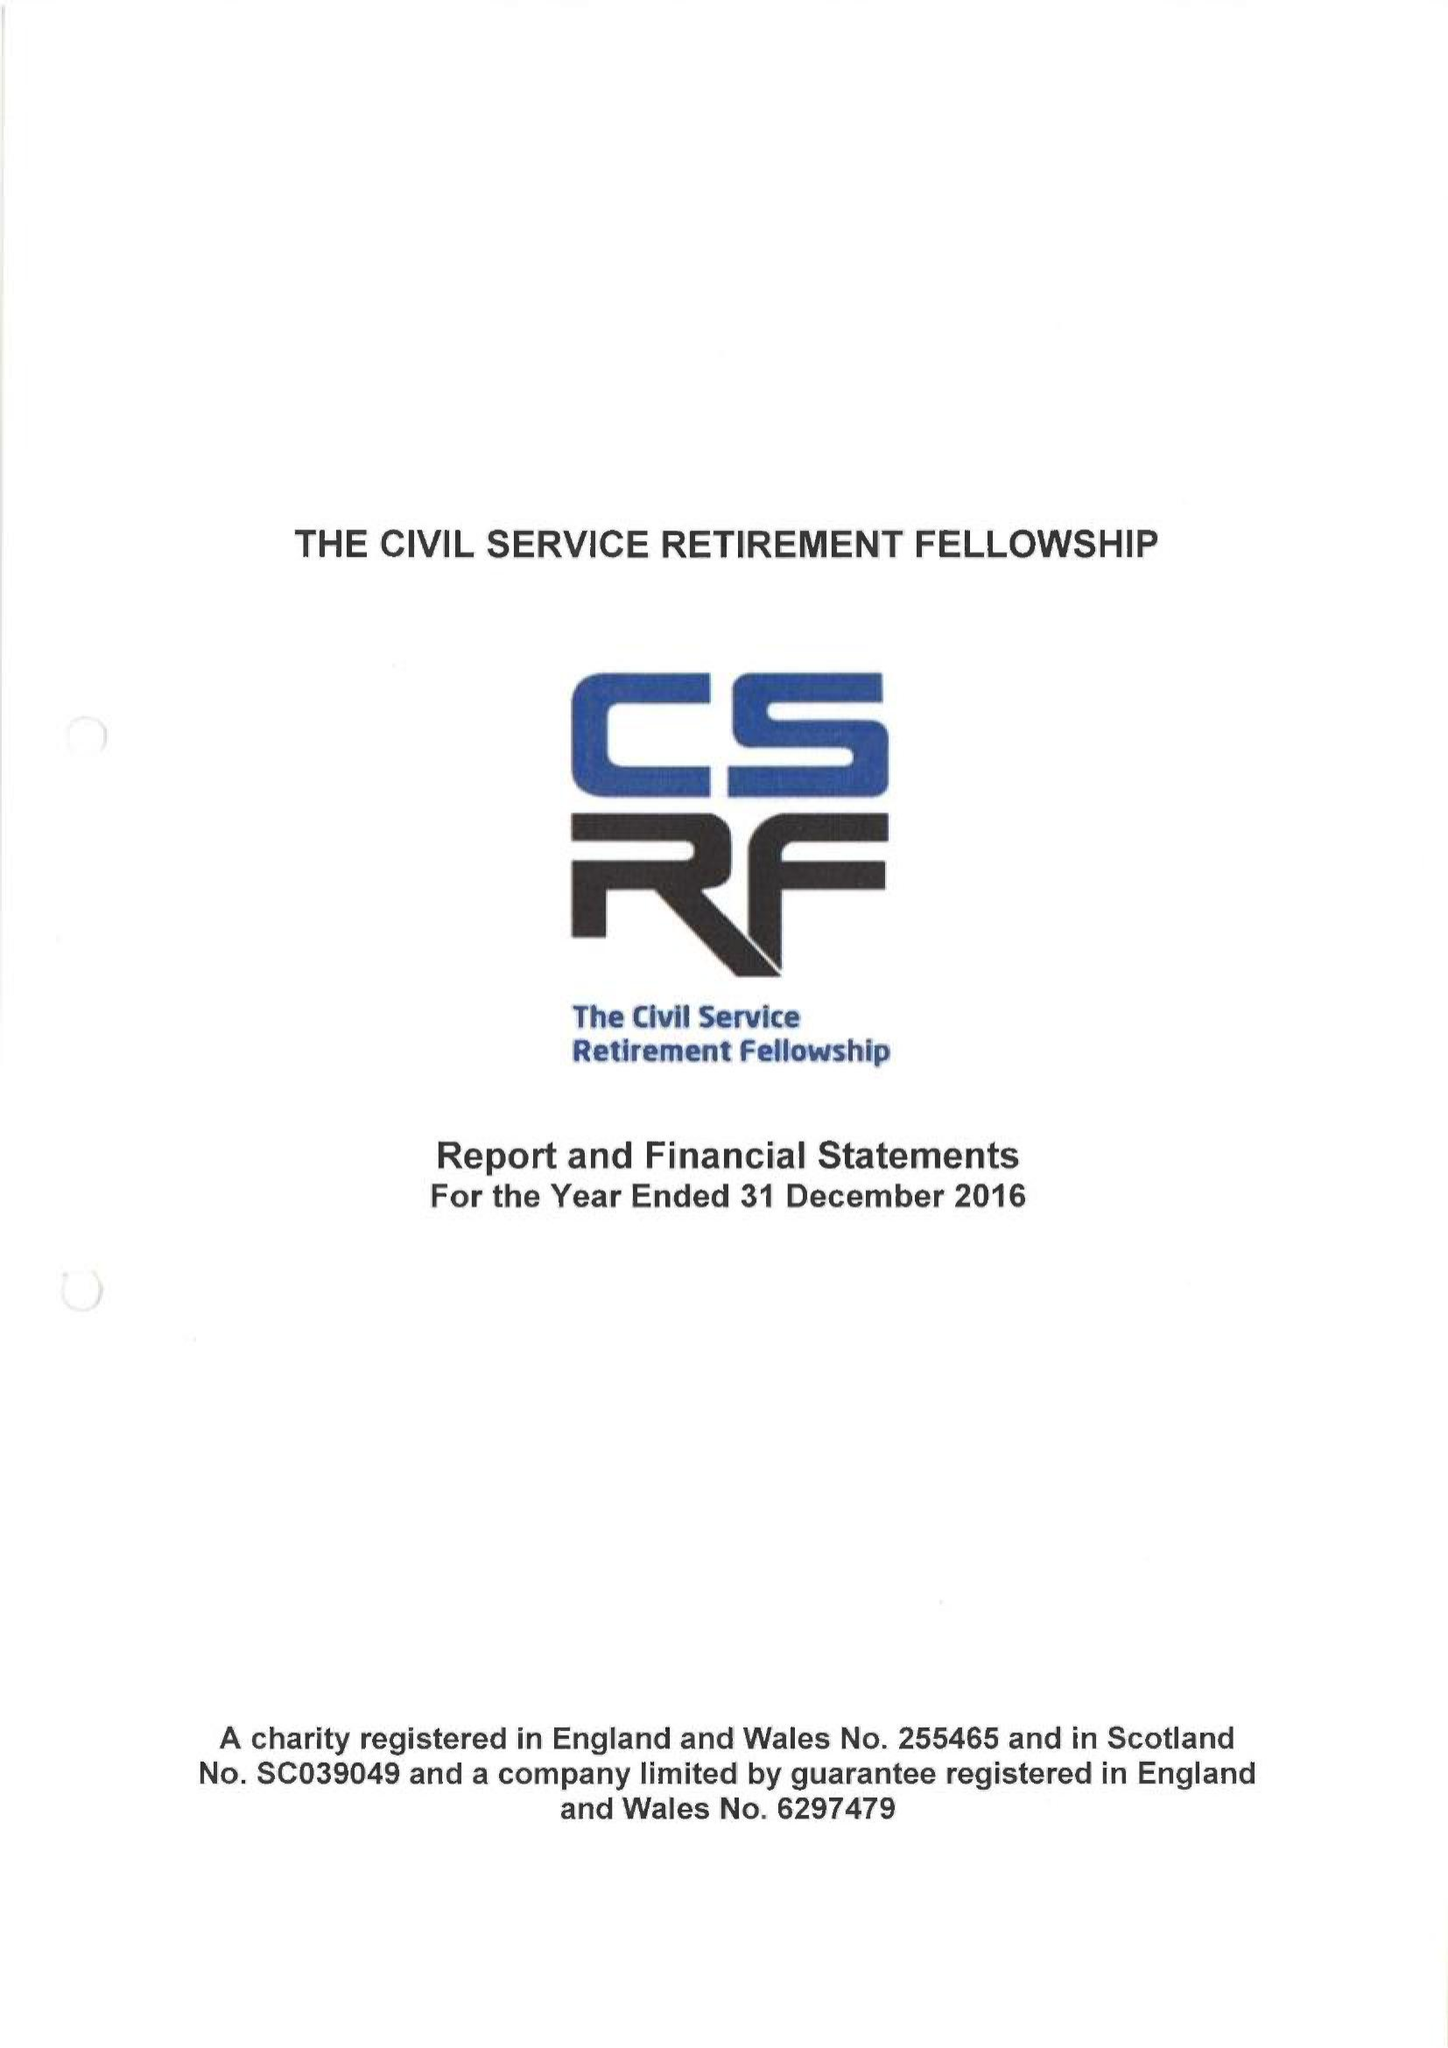What is the value for the address__postcode?
Answer the question using a single word or phrase. SE8 3EY 